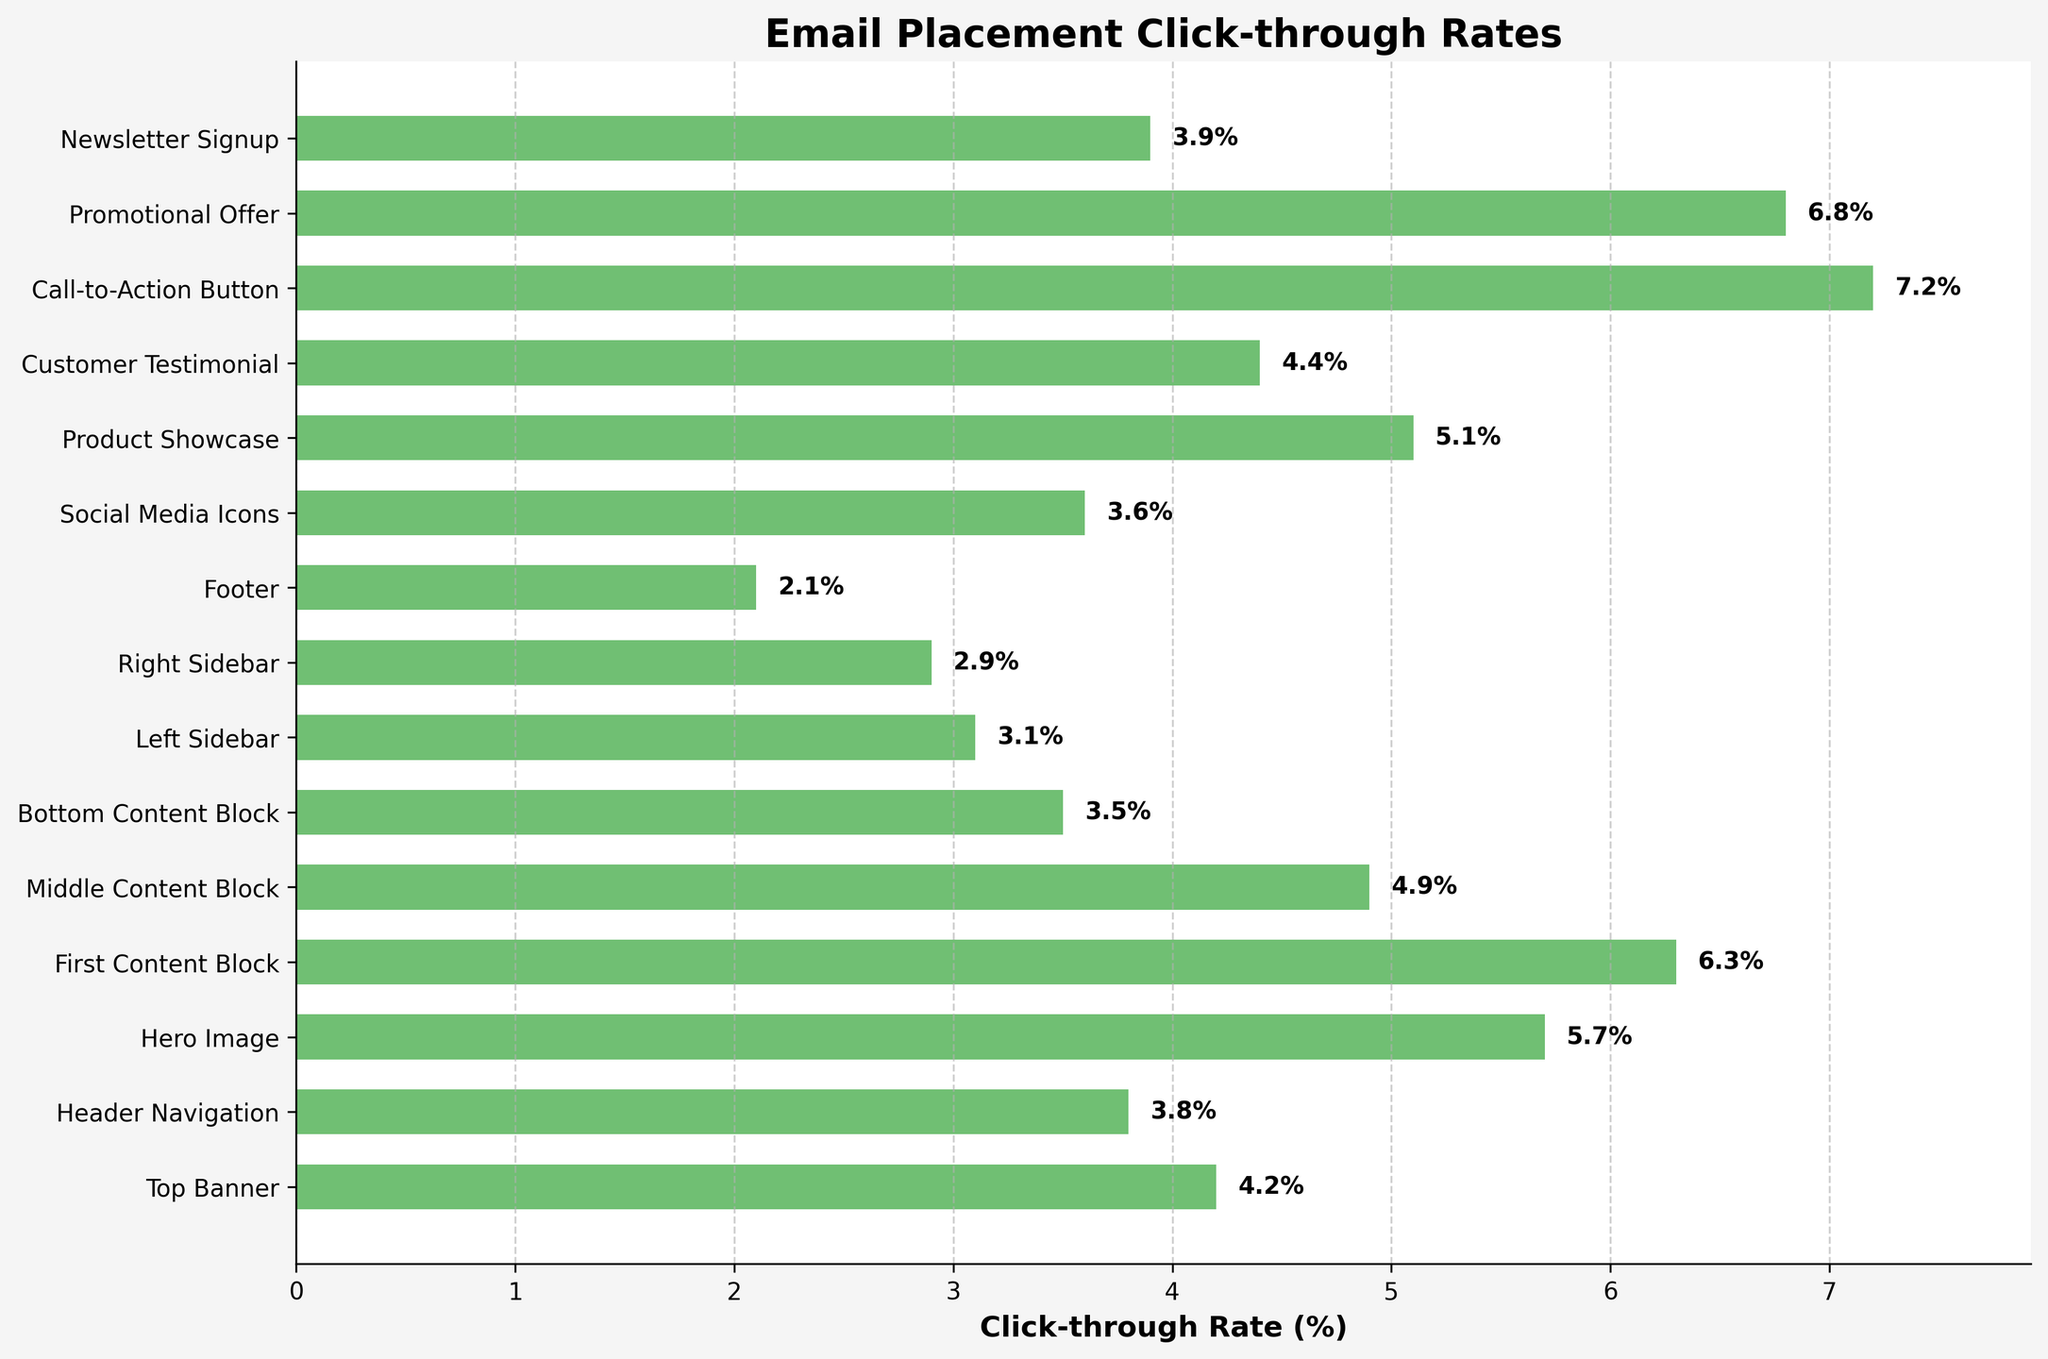What is the click-through rate for the "Call-to-Action Button"? Identify the bar labeled "Call-to-Action Button" and read its value.
Answer: 7.2% What position has the lowest click-through rate? Look for the position with the smallest bar length and lowest numerical value.
Answer: Footer How much higher is the click-through rate for the "First Content Block" compared to the "Bottom Content Block"? Subtract the click-through rate of "Bottom Content Block" from "First Content Block": 6.3 - 3.5 = 2.8
Answer: 2.8 Which two positions have click-through rates greater than 6%? Identify the bars with click-through rates above 6%:  "First Content Block" (6.3), "Promotional Offer" (6.8), and "Call-to-Action Button" (7.2).
Answer: First Content Block, Promotional Offer, Call-to-Action Button What is the difference in click-through rates between the "Hero Image" and "Product Showcase"? Subtract the click-through rate of "Product Showcase" from "Hero Image": 5.7 - 5.1 = 0.6
Answer: 0.6 How many positions have click-through rates between 3% and 4%? Identify the number of bars with click-through rates between 3% and 4%: "Header Navigation" (3.8), "Left Sidebar" (3.1), "Right Sidebar" (2.9), "Social Media Icons" (3.6), "Newsletter Signup" (3.9). Exclude those not within the range.
Answer: 3 What's the average click-through rate of all positions? Sum up the click-through rates and divide by the number of positions: (4.2 + 3.8 + 5.7 + 6.3 + 4.9 + 3.5 + 3.1 + 2.9 + 2.1 + 3.6 + 5.1 + 4.4 + 7.2 + 6.8 + 3.9) / 15 = 4.476
Answer: 4.48% Which position has a click-through rate closest to 5%? Compare the click-through rates and find the one nearest to 5%: "Middle Content Block" (4.9) and "Product Showcase" (5.1) are closest to 5%. Choose the closer one: (abs(4.9-5) = 0.1) < (abs(5.1-5) = 0.1). Middle Content Block
Answer: Middle Content Block How does the click-through rate of the "Top Banner" compare to that of "Header Navigation"? Compare the values: 4.2 (Top Banner) and 3.8 (Header Navigation). 4.2 is greater than 3.8.
Answer: Top Banner is higher 